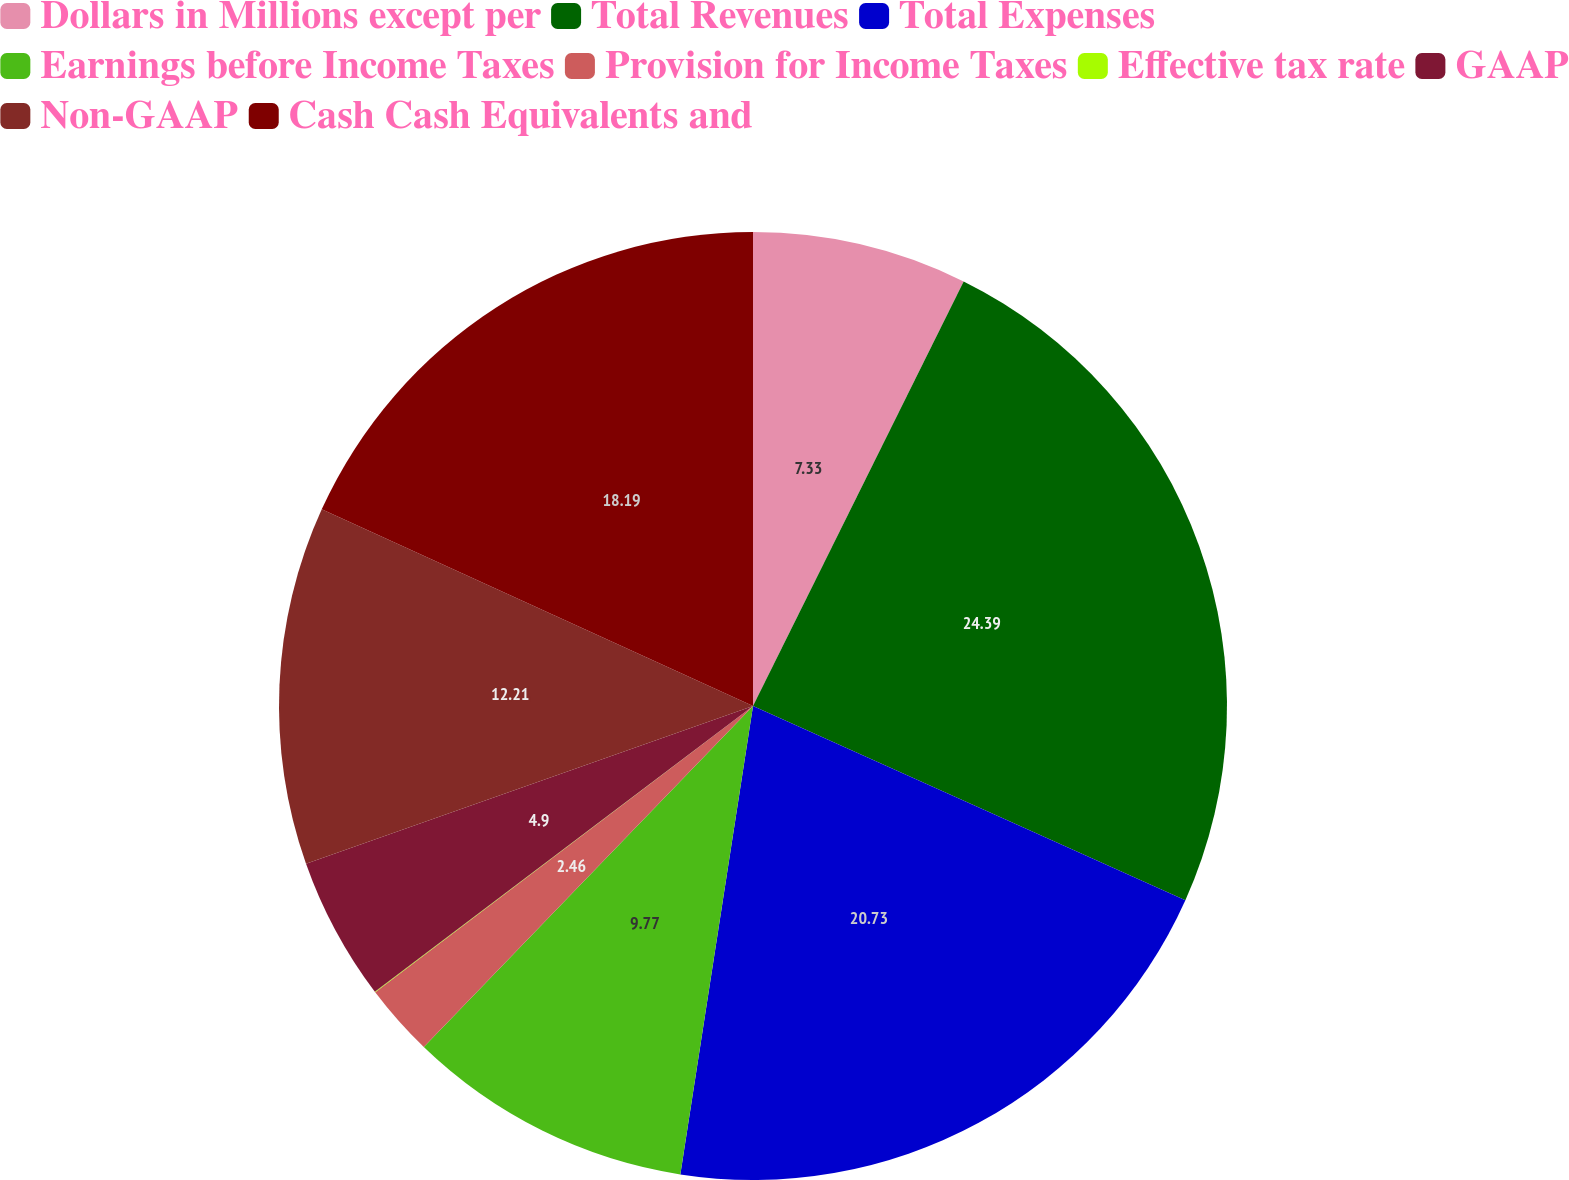Convert chart. <chart><loc_0><loc_0><loc_500><loc_500><pie_chart><fcel>Dollars in Millions except per<fcel>Total Revenues<fcel>Total Expenses<fcel>Earnings before Income Taxes<fcel>Provision for Income Taxes<fcel>Effective tax rate<fcel>GAAP<fcel>Non-GAAP<fcel>Cash Cash Equivalents and<nl><fcel>7.33%<fcel>24.39%<fcel>20.73%<fcel>9.77%<fcel>2.46%<fcel>0.02%<fcel>4.9%<fcel>12.21%<fcel>18.19%<nl></chart> 